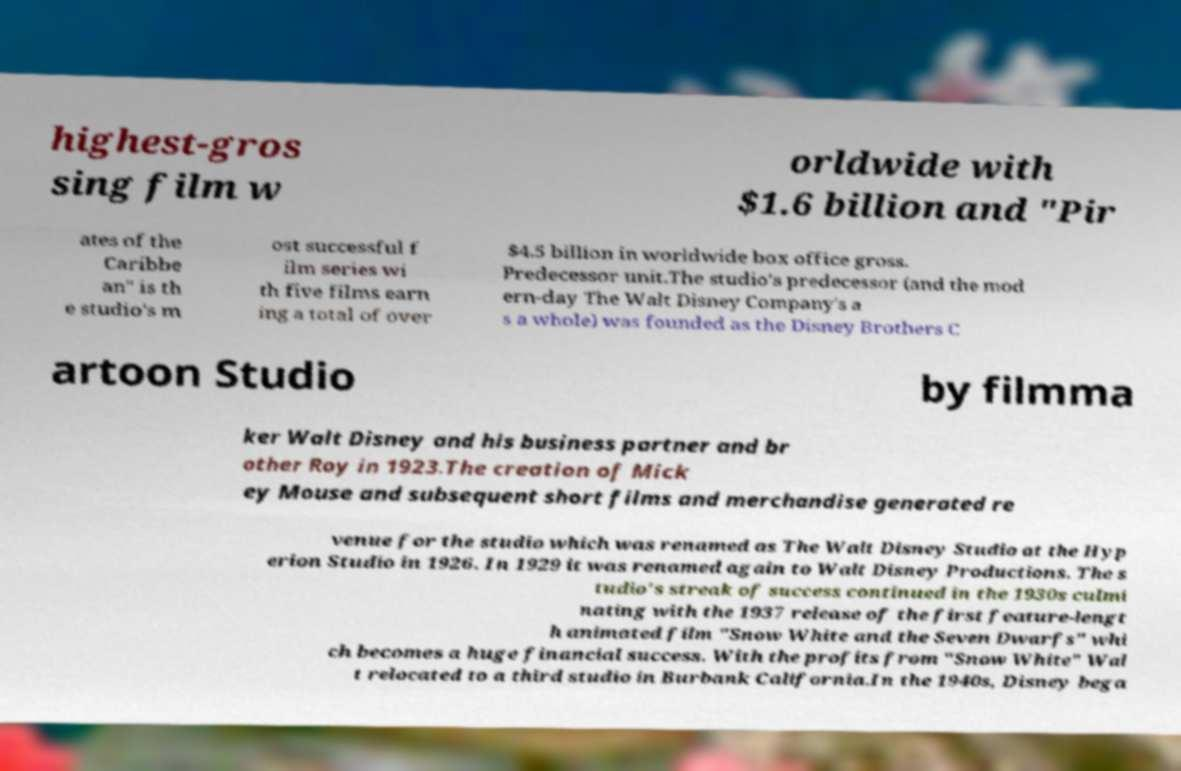There's text embedded in this image that I need extracted. Can you transcribe it verbatim? highest-gros sing film w orldwide with $1.6 billion and "Pir ates of the Caribbe an" is th e studio's m ost successful f ilm series wi th five films earn ing a total of over $4.5 billion in worldwide box office gross. Predecessor unit.The studio's predecessor (and the mod ern-day The Walt Disney Company's a s a whole) was founded as the Disney Brothers C artoon Studio by filmma ker Walt Disney and his business partner and br other Roy in 1923.The creation of Mick ey Mouse and subsequent short films and merchandise generated re venue for the studio which was renamed as The Walt Disney Studio at the Hyp erion Studio in 1926. In 1929 it was renamed again to Walt Disney Productions. The s tudio's streak of success continued in the 1930s culmi nating with the 1937 release of the first feature-lengt h animated film "Snow White and the Seven Dwarfs" whi ch becomes a huge financial success. With the profits from "Snow White" Wal t relocated to a third studio in Burbank California.In the 1940s, Disney bega 